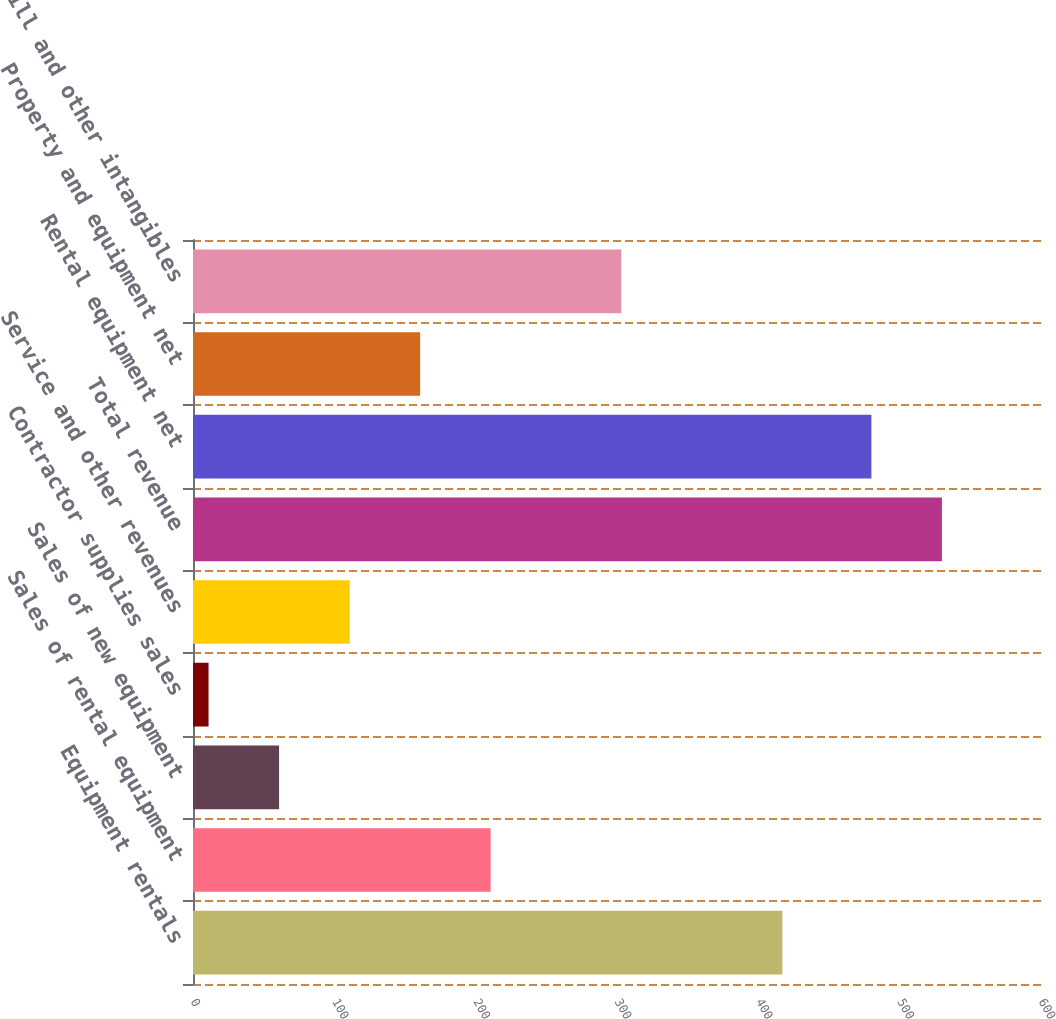<chart> <loc_0><loc_0><loc_500><loc_500><bar_chart><fcel>Equipment rentals<fcel>Sales of rental equipment<fcel>Sales of new equipment<fcel>Contractor supplies sales<fcel>Service and other revenues<fcel>Total revenue<fcel>Rental equipment net<fcel>Property and equipment net<fcel>Goodwill and other intangibles<nl><fcel>417<fcel>210.6<fcel>60.9<fcel>11<fcel>110.8<fcel>529.9<fcel>480<fcel>160.7<fcel>303<nl></chart> 